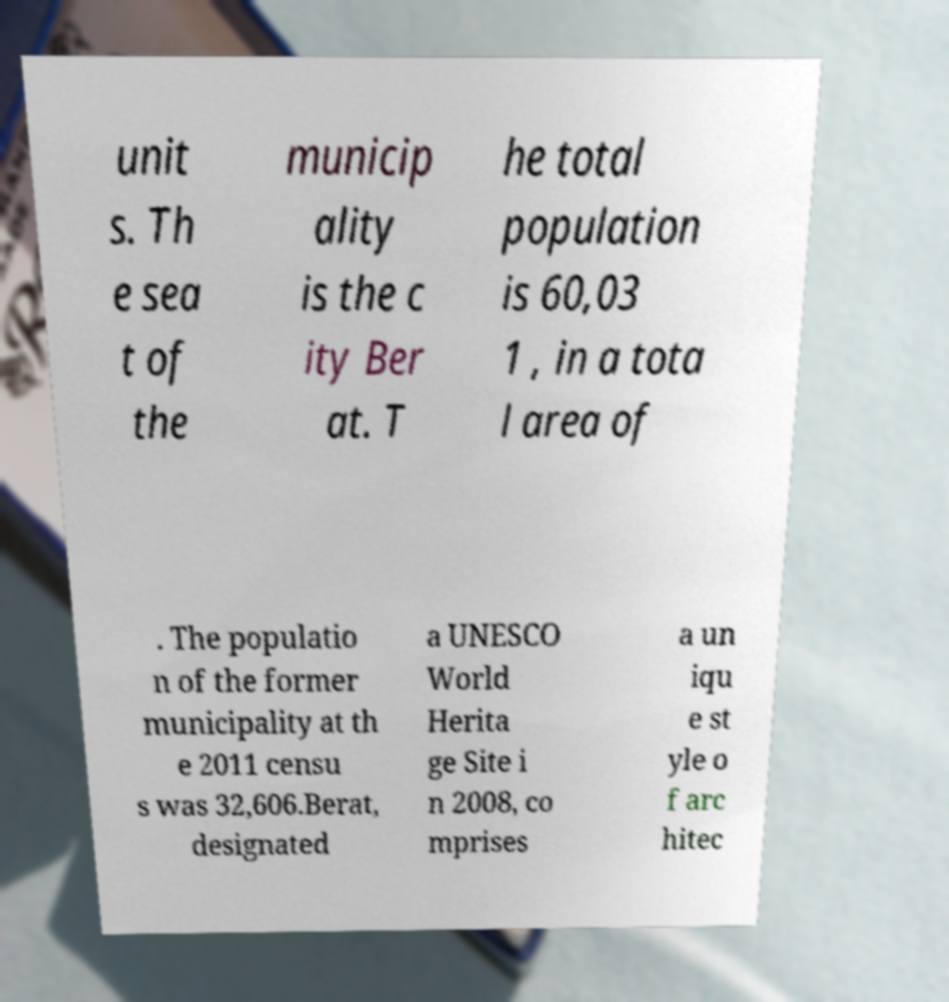Could you extract and type out the text from this image? unit s. Th e sea t of the municip ality is the c ity Ber at. T he total population is 60,03 1 , in a tota l area of . The populatio n of the former municipality at th e 2011 censu s was 32,606.Berat, designated a UNESCO World Herita ge Site i n 2008, co mprises a un iqu e st yle o f arc hitec 